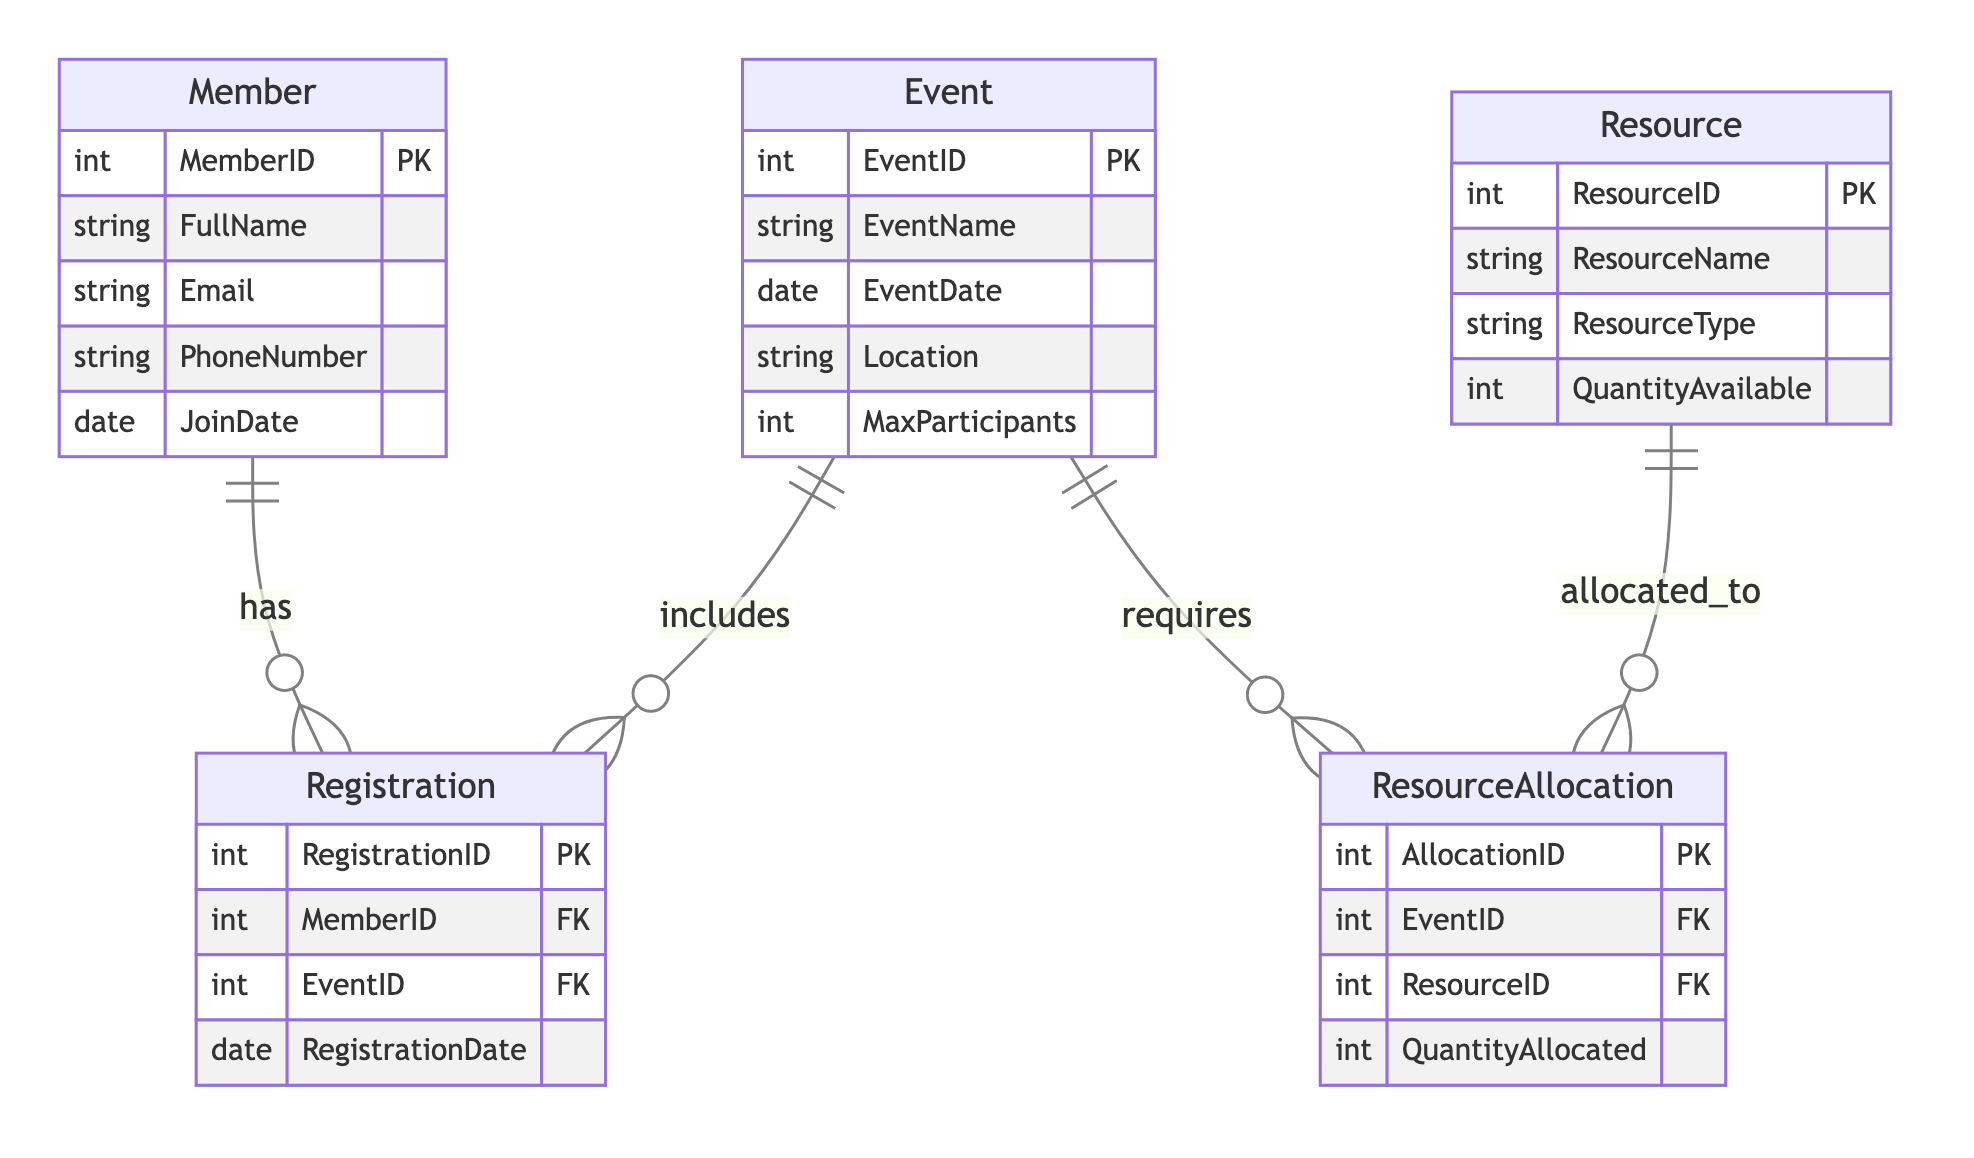What is the primary key of the Member entity? The primary key of the Member entity is indicated in the diagram, where the MemberID is denoted as PK (Primary Key).
Answer: MemberID How many attributes does the Event entity have? The Event entity has five attributes listed in the diagram: EventID, EventName, EventDate, Location, and MaxParticipants.
Answer: Five What is the relationship type between Member and Registration? The relationship type is specified as OneToMany in the diagram, which indicates that one member can have multiple registrations.
Answer: OneToMany Which entity is the ResourceAllocation dependent on? The ResourceAllocation is dependent on both Event and Resource entities as shown by the foreign keys. However, since the question asks for one entity, we can say it primarily depends on the Event, as allocations cannot exist without an event.
Answer: Event How many foreign keys are present in the Registration entity? The Registration entity contains two foreign keys: MemberID and EventID, as specified in the diagram.
Answer: Two If a member registers for an event, what two entities are involved? When a member registers for an event, both the Member and Registration entities are involved, as the Registration serves as a link between members and events.
Answer: Member and Registration What does the Resource entity represent in this diagram? The Resource entity represents assets or materials that can be allocated for events, including information such as ResourceName and QuantityAvailable.
Answer: Assets How many relationships are displayed in the diagram? The diagram displays four relationships, linking various entities together: Member with Registration, Event with Registration, Event with ResourceAllocation, and Resource with ResourceAllocation.
Answer: Four What type of relationship exists between Event and ResourceAllocation? According to the diagram, the relationship between Event and ResourceAllocation is characterized as OneToMany, meaning one event can have multiple resource allocations.
Answer: OneToMany 